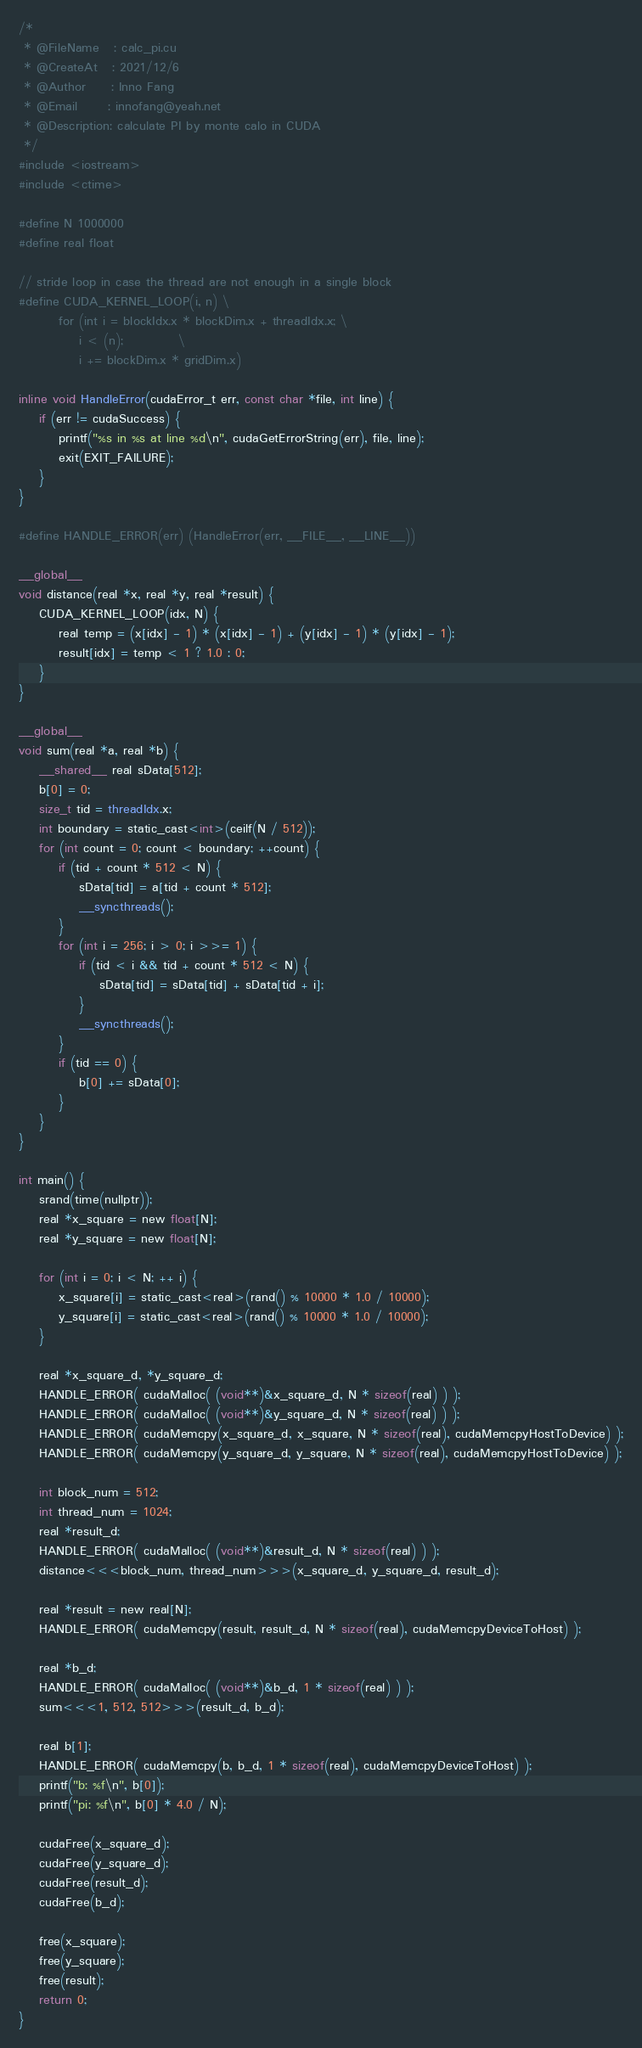<code> <loc_0><loc_0><loc_500><loc_500><_Cuda_>/*
 * @FileName   : calc_pi.cu
 * @CreateAt   : 2021/12/6
 * @Author     : Inno Fang
 * @Email      : innofang@yeah.net
 * @Description: calculate PI by monte calo in CUDA
 */
#include <iostream>
#include <ctime>

#define N 1000000
#define real float

// stride loop in case the thread are not enough in a single block
#define CUDA_KERNEL_LOOP(i, n) \
        for (int i = blockIdx.x * blockDim.x + threadIdx.x; \
            i < (n);           \
            i += blockDim.x * gridDim.x)

inline void HandleError(cudaError_t err, const char *file, int line) {
    if (err != cudaSuccess) {
        printf("%s in %s at line %d\n", cudaGetErrorString(err), file, line);
        exit(EXIT_FAILURE);
    }
}

#define HANDLE_ERROR(err) (HandleError(err, __FILE__, __LINE__))

__global__
void distance(real *x, real *y, real *result) {
    CUDA_KERNEL_LOOP(idx, N) {
        real temp = (x[idx] - 1) * (x[idx] - 1) + (y[idx] - 1) * (y[idx] - 1);
        result[idx] = temp < 1 ? 1.0 : 0;
    }
}

__global__
void sum(real *a, real *b) {
    __shared__ real sData[512];
    b[0] = 0;
    size_t tid = threadIdx.x;
    int boundary = static_cast<int>(ceilf(N / 512));
    for (int count = 0; count < boundary; ++count) {
        if (tid + count * 512 < N) {
            sData[tid] = a[tid + count * 512];
            __syncthreads();
        }
        for (int i = 256; i > 0; i >>= 1) {
            if (tid < i && tid + count * 512 < N) {
                sData[tid] = sData[tid] + sData[tid + i];
            }
            __syncthreads();
        }
        if (tid == 0) {
            b[0] += sData[0];
        }
    }
}

int main() {
    srand(time(nullptr));
    real *x_square = new float[N];
    real *y_square = new float[N];

    for (int i = 0; i < N; ++ i) {
        x_square[i] = static_cast<real>(rand() % 10000 * 1.0 / 10000);
        y_square[i] = static_cast<real>(rand() % 10000 * 1.0 / 10000);
    }

    real *x_square_d, *y_square_d;
    HANDLE_ERROR( cudaMalloc( (void**)&x_square_d, N * sizeof(real) ) );
    HANDLE_ERROR( cudaMalloc( (void**)&y_square_d, N * sizeof(real) ) );
    HANDLE_ERROR( cudaMemcpy(x_square_d, x_square, N * sizeof(real), cudaMemcpyHostToDevice) );
    HANDLE_ERROR( cudaMemcpy(y_square_d, y_square, N * sizeof(real), cudaMemcpyHostToDevice) );

    int block_num = 512;
    int thread_num = 1024;
    real *result_d;
    HANDLE_ERROR( cudaMalloc( (void**)&result_d, N * sizeof(real) ) );
    distance<<<block_num, thread_num>>>(x_square_d, y_square_d, result_d);

    real *result = new real[N];
    HANDLE_ERROR( cudaMemcpy(result, result_d, N * sizeof(real), cudaMemcpyDeviceToHost) );

    real *b_d;
    HANDLE_ERROR( cudaMalloc( (void**)&b_d, 1 * sizeof(real) ) );
    sum<<<1, 512, 512>>>(result_d, b_d);

    real b[1];
    HANDLE_ERROR( cudaMemcpy(b, b_d, 1 * sizeof(real), cudaMemcpyDeviceToHost) );
    printf("b: %f\n", b[0]);
    printf("pi: %f\n", b[0] * 4.0 / N);

    cudaFree(x_square_d);
    cudaFree(y_square_d);
    cudaFree(result_d);
    cudaFree(b_d);

    free(x_square);
    free(y_square);
    free(result);
    return 0;
}

</code> 